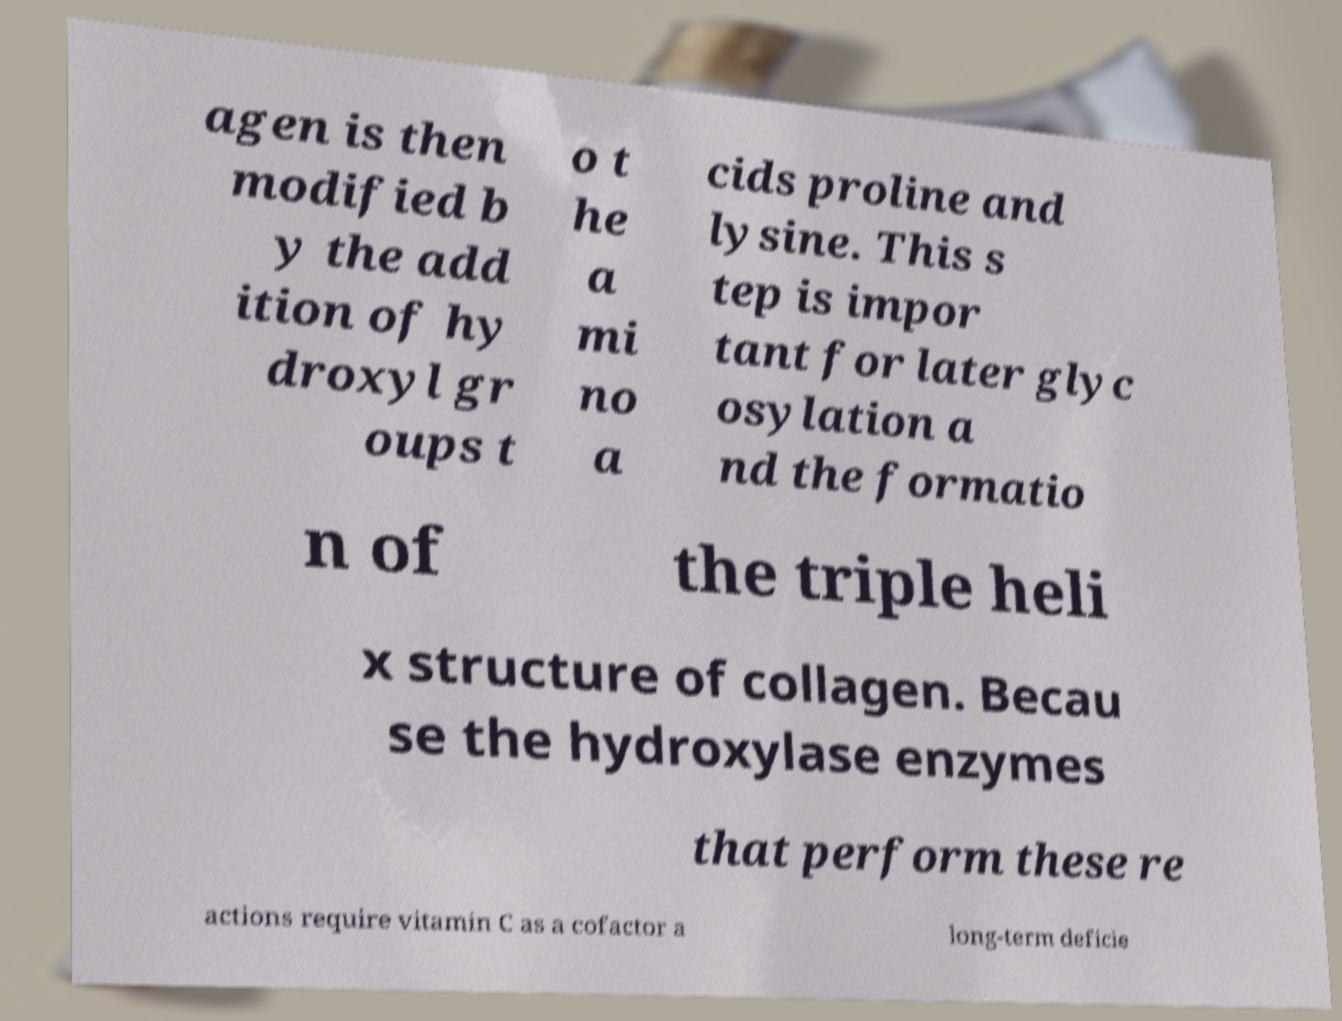There's text embedded in this image that I need extracted. Can you transcribe it verbatim? agen is then modified b y the add ition of hy droxyl gr oups t o t he a mi no a cids proline and lysine. This s tep is impor tant for later glyc osylation a nd the formatio n of the triple heli x structure of collagen. Becau se the hydroxylase enzymes that perform these re actions require vitamin C as a cofactor a long-term deficie 